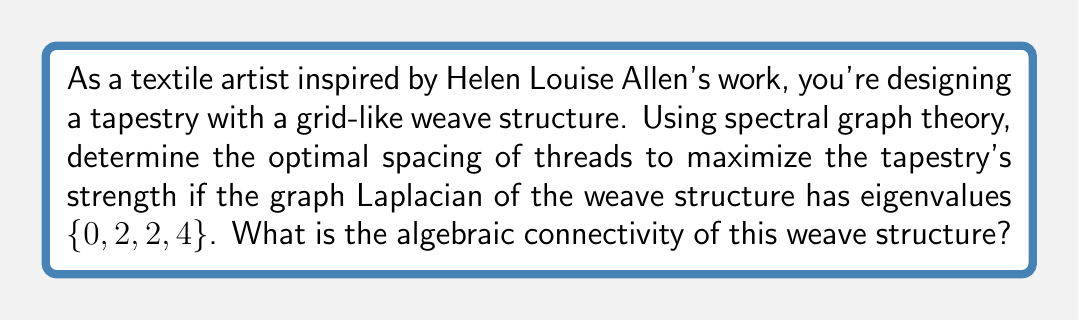What is the answer to this math problem? To solve this problem, we'll follow these steps:

1) In spectral graph theory, the algebraic connectivity of a graph is defined as the second smallest eigenvalue of the graph Laplacian matrix. This value is also known as the Fiedler value.

2) The given eigenvalues of the graph Laplacian are $\{0, 2, 2, 4\}$.

3) We know that for any connected graph, the smallest eigenvalue of the Laplacian is always 0. This corresponds to the first value in our set.

4) The second smallest eigenvalue, which is the algebraic connectivity, will be the next distinct value in the sorted list of eigenvalues.

5) In this case, the second smallest eigenvalue is 2.

6) The algebraic connectivity provides information about the overall connectivity and robustness of the graph structure. A higher value indicates a more strongly connected structure.

7) In the context of weaving, a higher algebraic connectivity suggests a more stable and strong weave structure. The optimal spacing of threads would be one that maximizes this value while still maintaining the desired aesthetic and flexibility of the fabric.

Therefore, the algebraic connectivity of this weave structure is 2, indicating a moderately strong connection between the threads in the tapestry.
Answer: 2 